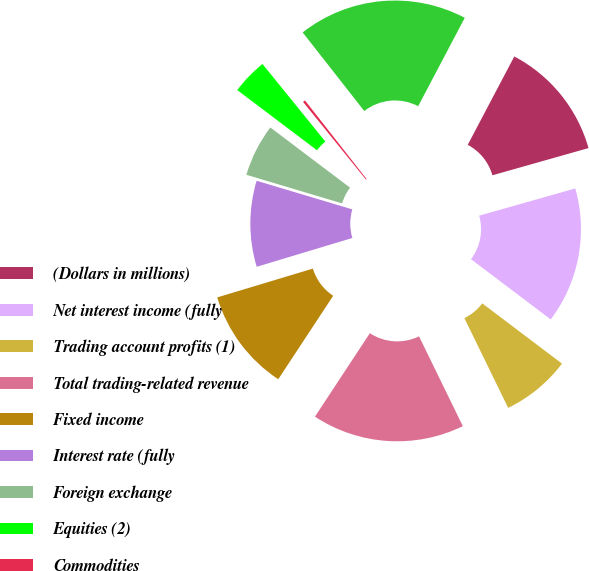Convert chart. <chart><loc_0><loc_0><loc_500><loc_500><pie_chart><fcel>(Dollars in millions)<fcel>Net interest income (fully<fcel>Trading account profits (1)<fcel>Total trading-related revenue<fcel>Fixed income<fcel>Interest rate (fully<fcel>Foreign exchange<fcel>Equities (2)<fcel>Commodities<fcel>Market-based trading-related<nl><fcel>12.89%<fcel>14.69%<fcel>7.48%<fcel>16.49%<fcel>11.08%<fcel>9.28%<fcel>5.67%<fcel>3.87%<fcel>0.26%<fcel>18.3%<nl></chart> 